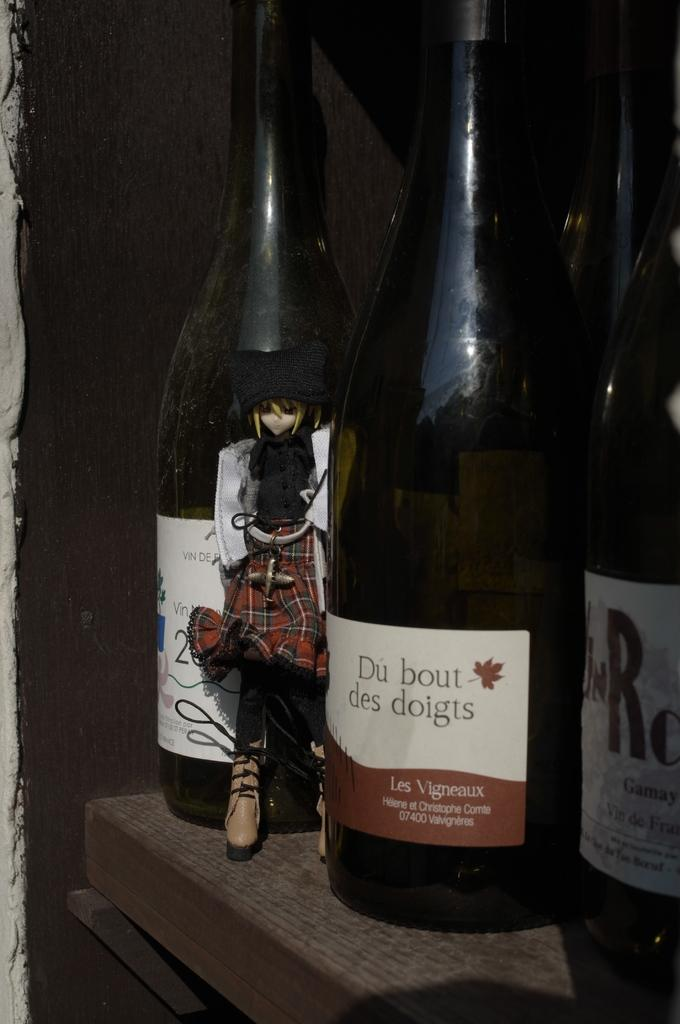<image>
Describe the image concisely. Two bottles of wine are displayed with one reading Du bout Des dolgis on its label. 